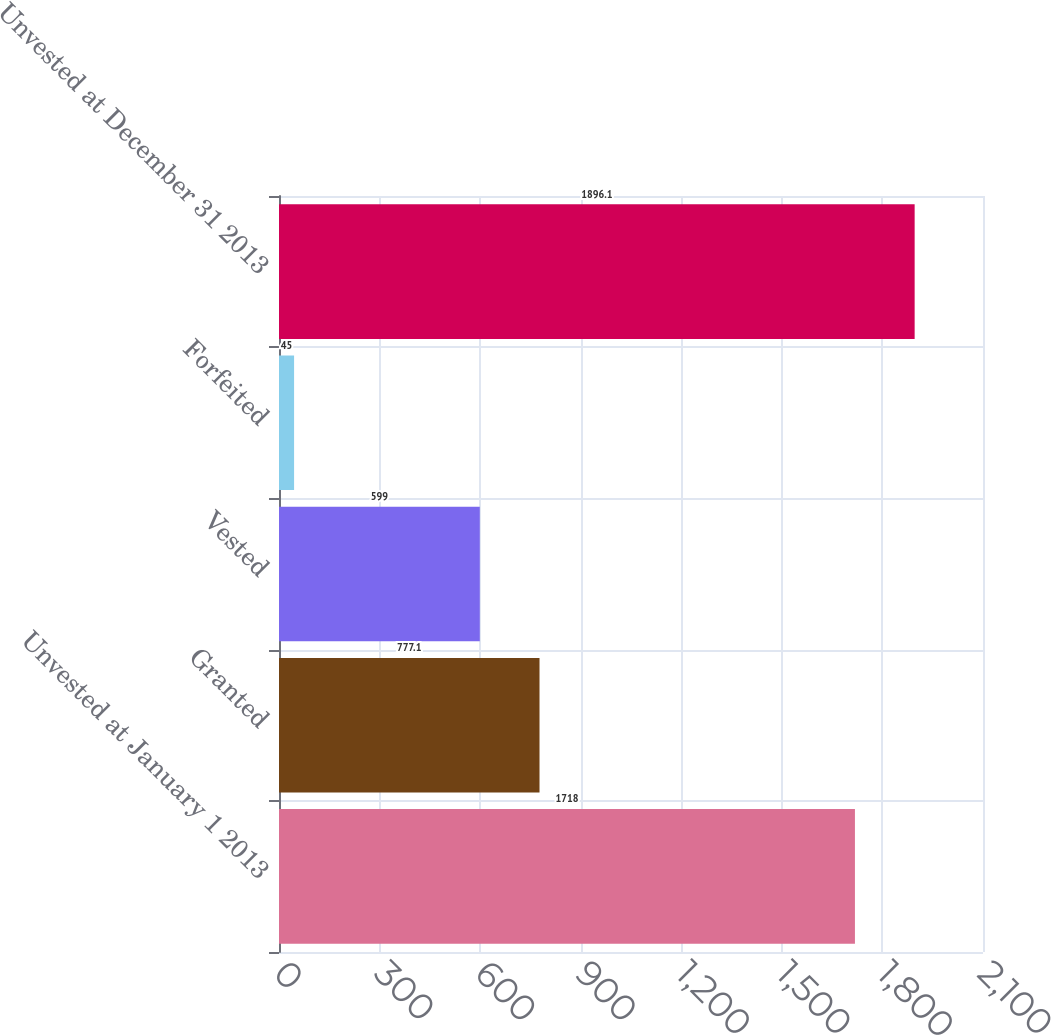Convert chart to OTSL. <chart><loc_0><loc_0><loc_500><loc_500><bar_chart><fcel>Unvested at January 1 2013<fcel>Granted<fcel>Vested<fcel>Forfeited<fcel>Unvested at December 31 2013<nl><fcel>1718<fcel>777.1<fcel>599<fcel>45<fcel>1896.1<nl></chart> 